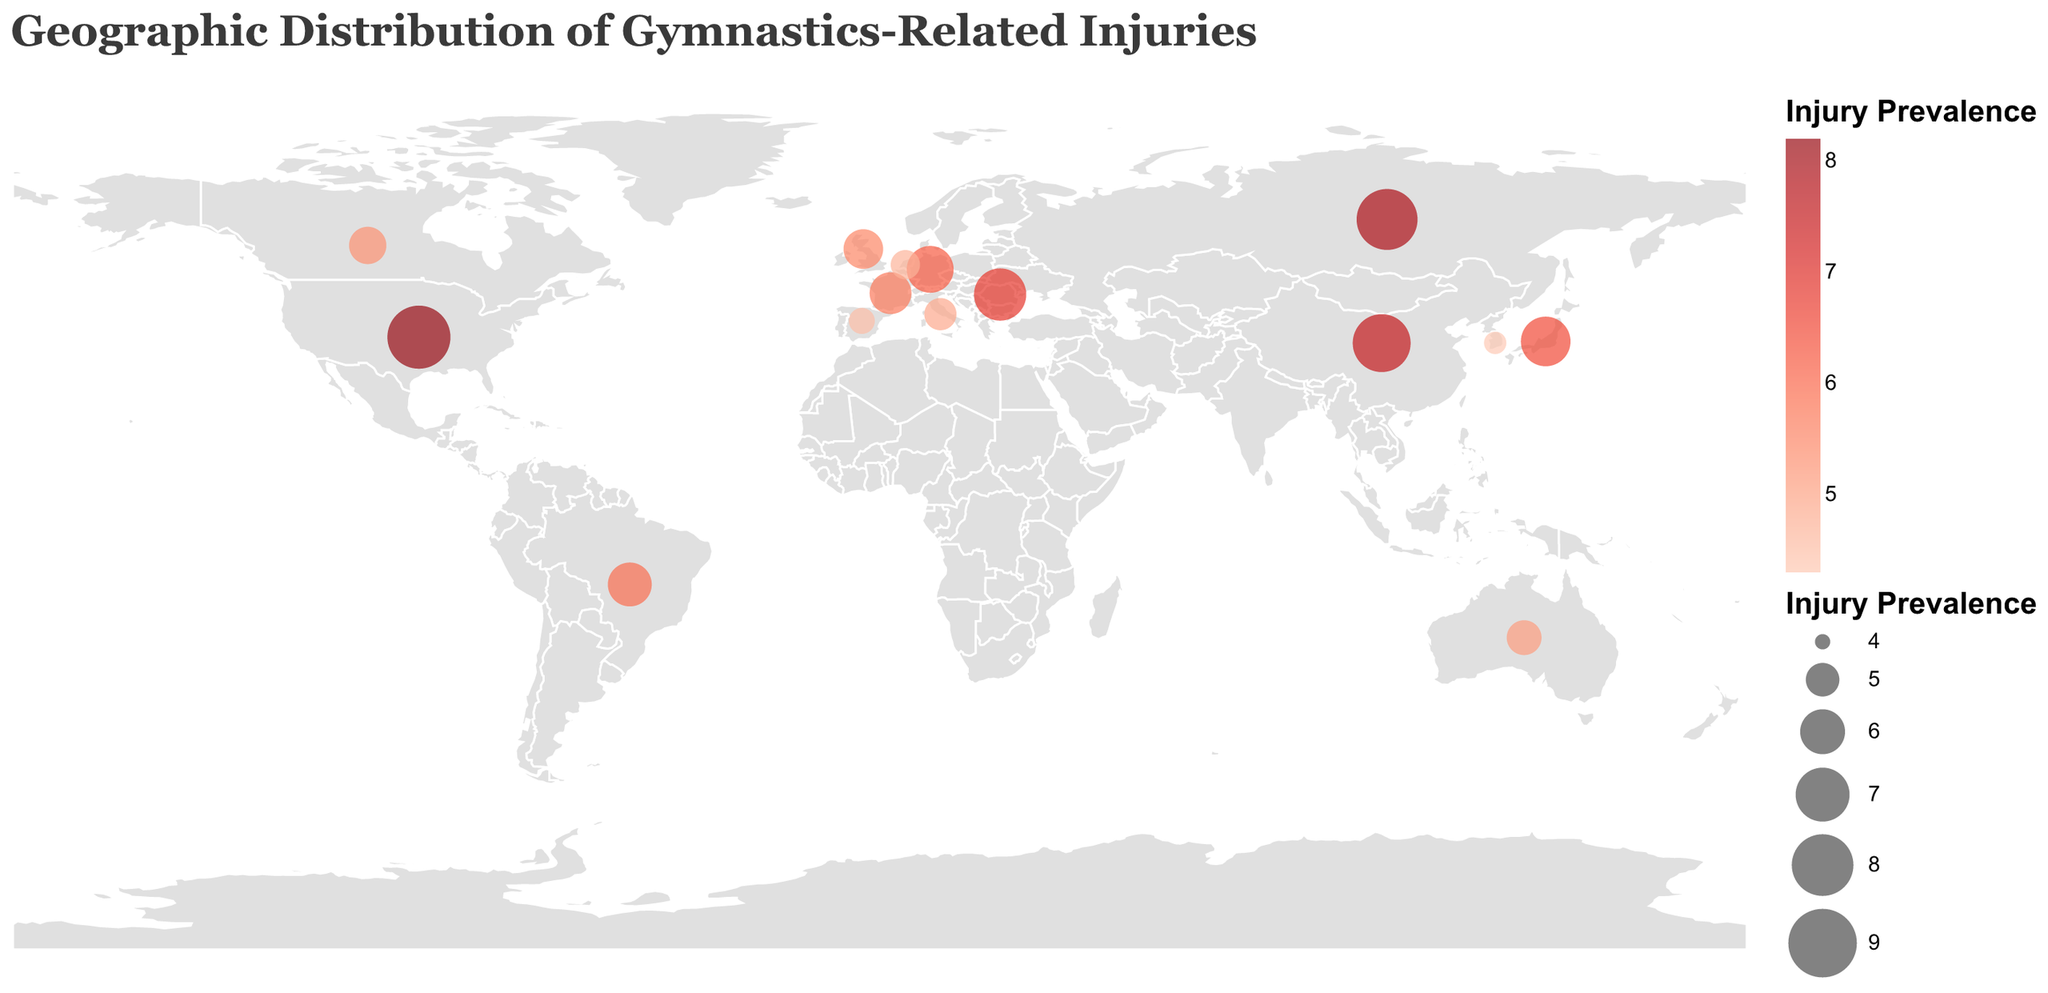What is the title of the figure? The title of any figure can be found at the top. In this case, it reads "Geographic Distribution of Gymnastics-Related Injuries"
Answer: Geographic Distribution of Gymnastics-Related Injuries Which country has the highest injury prevalence? By looking at the circles on the map, the largest and darkest red circle indicates the highest prevalence, which is over the United States with an injury prevalence of 8.2
Answer: United States What is the most common injury in Russia? The data points are marked on the map and include the most common injury type. By finding Russia, we see the tooltip indicates the most common injury as Lower Back Strain
Answer: Lower Back Strain How does the injury prevalence in China compare to that in Germany? From the figure, we can compare the size and color of the circles over China and Germany. China's injury prevalence is 7.5, which is higher than Germany's 6.2
Answer: China has a higher injury prevalence than Germany What is the average injury prevalence for all the countries? Sum up all the injury prevalence values and then divide by the number of countries. The sum is 8.2 + 7.9 + 7.5 + 6.8 + 6.5 + 6.2 + 5.9 + 5.7 + 5.5 + 5.3 + 5.1 + 4.9 + 4.7 + 4.5 + 4.3 = 84.1. There are 15 countries, so the average is 84.1 / 15 ≈ 5.61
Answer: 5.61 Which country has the lowest injury prevalence and what is it? By identifying the smallest and lightest red circle on the map, we can determine the country. South Korea has the lowest injury prevalence at 4.3
Answer: South Korea, 4.3 Are there any countries with the same most common injury? We can check the tooltip information for each country to find if any country pairs share the same injury type. There are no duplicate most common injuries for any two countries
Answer: No Which two countries have the closest injury prevalence figures to each other? By comparing all presented injury prevalence values, Brazil (5.9) and France (5.7) have the closest figures with a difference of 0.2
Answer: Brazil and France What is the sum of injury prevalence for countries in Europe? The countries in Europe from the dataset are Romania, Germany, France, Great Britain, Italy, Netherlands, and Spain. Summing their values: 6.8 + 6.2 + 5.7 + 5.5 + 4.9 + 4.7 + 4.5 = 38.3
Answer: 38.3 Which region has a higher prevalence of ankle-related injuries: North America or Europe? In the dataset, the only country with an ankle-related injury (Ankle Sprain) is in North America, specifically the United States, with no countries in Europe listed with ankle-related injuries
Answer: North America 